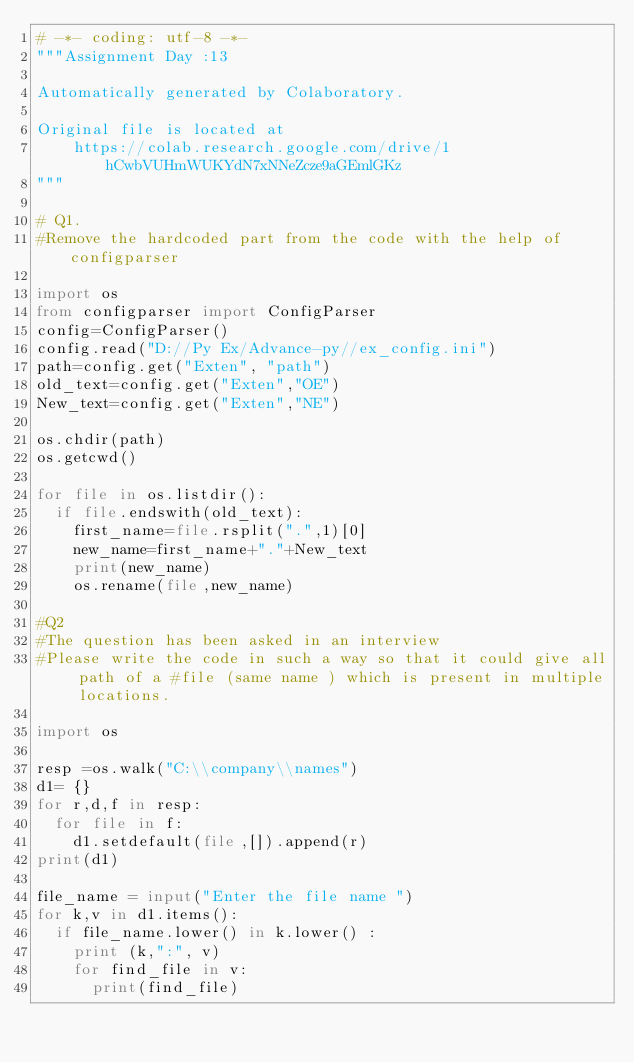Convert code to text. <code><loc_0><loc_0><loc_500><loc_500><_Python_># -*- coding: utf-8 -*-
"""Assignment Day :13

Automatically generated by Colaboratory.

Original file is located at
    https://colab.research.google.com/drive/1hCwbVUHmWUKYdN7xNNeZcze9aGEmlGKz
"""

# Q1.
#Remove the hardcoded part from the code with the help of configparser

import os
from configparser import ConfigParser
config=ConfigParser()
config.read("D://Py Ex/Advance-py//ex_config.ini")
path=config.get("Exten", "path")
old_text=config.get("Exten","OE")
New_text=config.get("Exten","NE")

os.chdir(path)
os.getcwd()

for file in os.listdir():
  if file.endswith(old_text):
    first_name=file.rsplit(".",1)[0]
    new_name=first_name+"."+New_text
    print(new_name)
    os.rename(file,new_name)

#Q2
#The question has been asked in an interview
#Please write the code in such a way so that it could give all path of a #file (same name ) which is present in multiple locations.

import os

resp =os.walk("C:\\company\\names")
d1= {}
for r,d,f in resp:
  for file in f:
    d1.setdefault(file,[]).append(r)
print(d1)

file_name = input("Enter the file name ")
for k,v in d1.items():
  if file_name.lower() in k.lower() :
    print (k,":", v)
    for find_file in v:
      print(find_file)</code> 